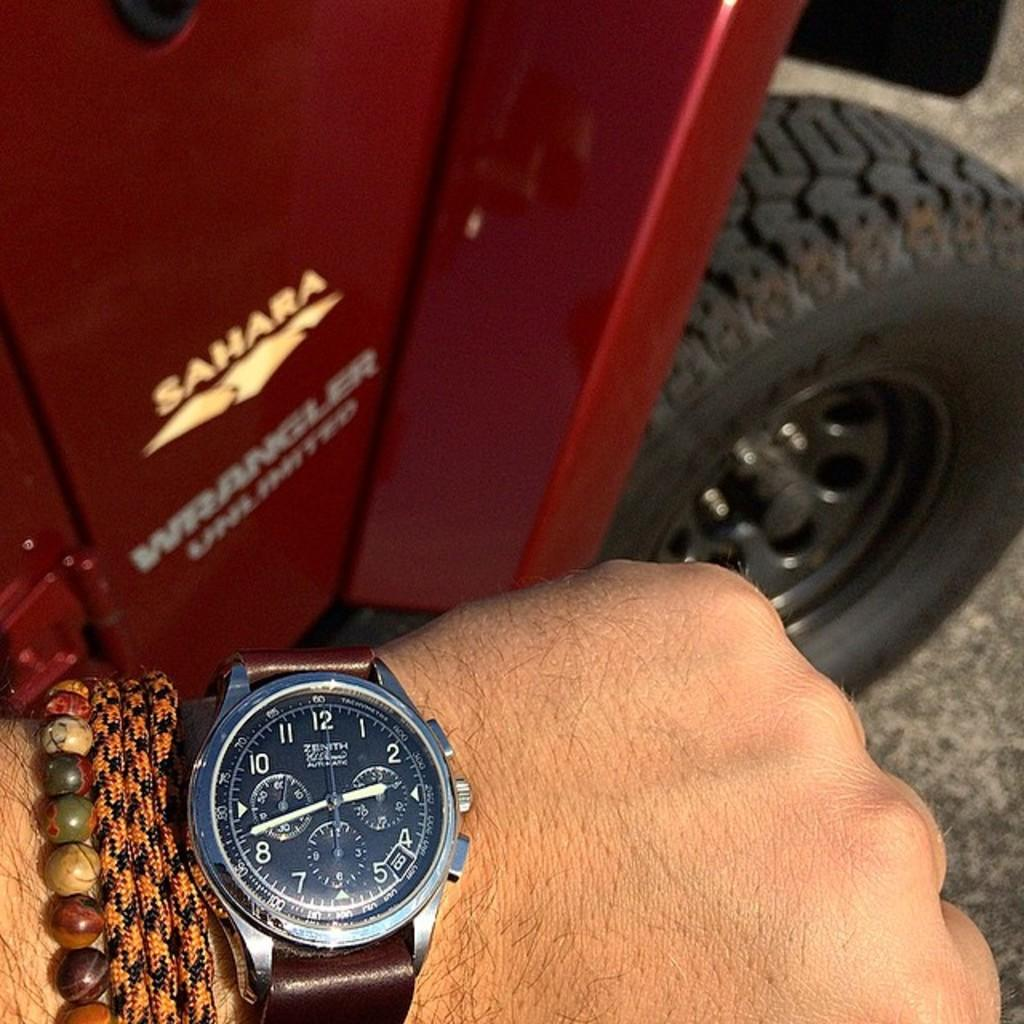<image>
Describe the image concisely. A Zenith watch being shown off in front of a Jeep Wrangler Sahara. 